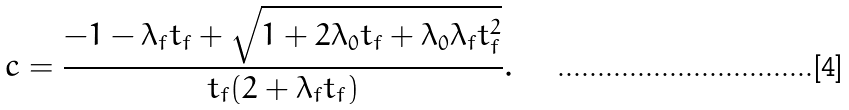<formula> <loc_0><loc_0><loc_500><loc_500>c = \frac { - 1 - \lambda _ { f } t _ { f } + \sqrt { 1 + 2 \lambda _ { 0 } t _ { f } + \lambda _ { 0 } \lambda _ { f } t _ { f } ^ { 2 } } } { t _ { f } ( 2 + \lambda _ { f } t _ { f } ) } .</formula> 